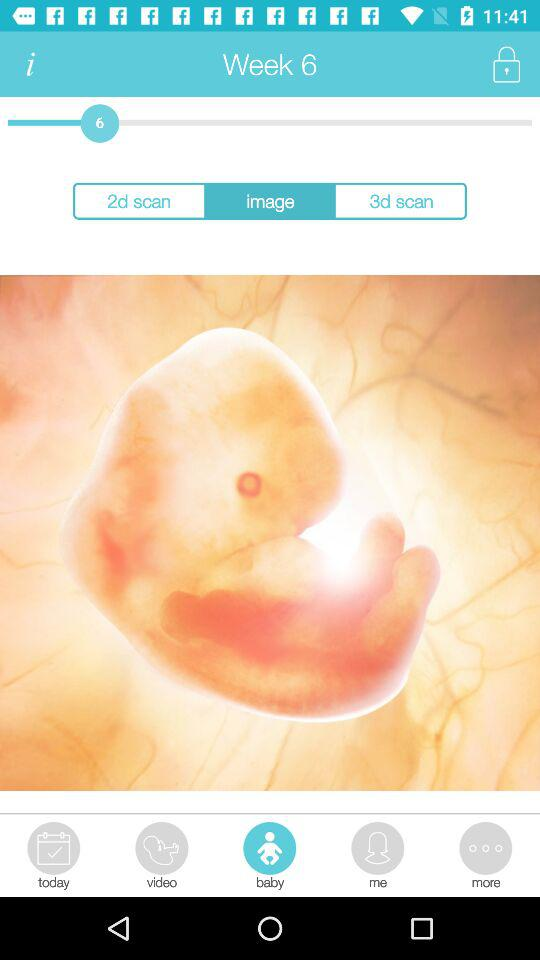Which tab is selected? The selected tab is "baby". 